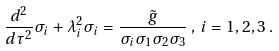Convert formula to latex. <formula><loc_0><loc_0><loc_500><loc_500>\frac { d ^ { 2 } } { d \tau ^ { 2 } } \sigma _ { i } + \lambda _ { i } ^ { 2 } \sigma _ { i } = \frac { \tilde { g } } { \sigma _ { i } \sigma _ { 1 } \sigma _ { 2 } \sigma _ { 3 } } \, , \, i = 1 , 2 , 3 \, .</formula> 